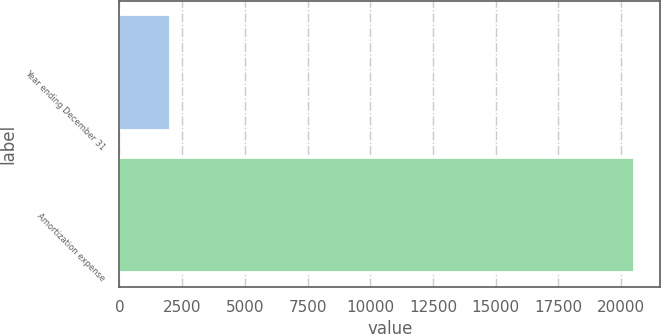Convert chart to OTSL. <chart><loc_0><loc_0><loc_500><loc_500><bar_chart><fcel>Year ending December 31<fcel>Amortization expense<nl><fcel>2018<fcel>20529<nl></chart> 